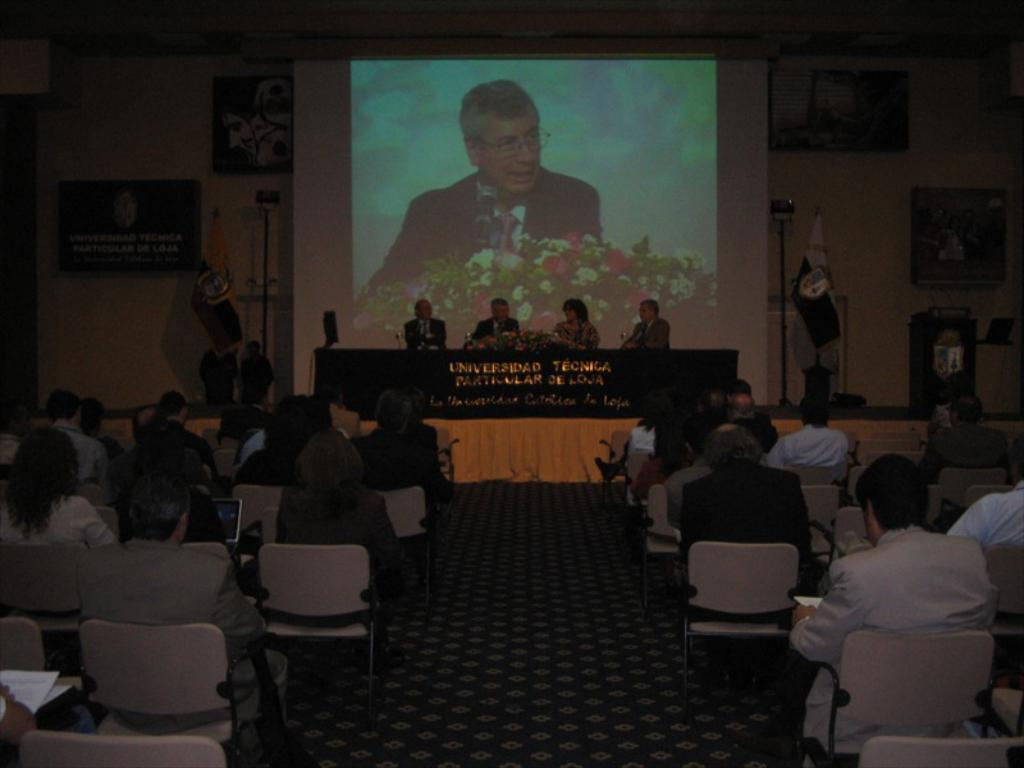What are the people in the image doing? There is a group of people sitting on chairs in the image. What can be seen on the wall behind the people? Boards are attached to the wall in the image. What is the purpose of the screen visible in the image? The purpose of the screen is not specified, but it is visible in the image. What is the flag associated with in the image? The flag is present in the image, but its specific association is not mentioned. What hobbies do the people sitting on chairs have in common? There is no information provided about the hobbies of the people sitting on chairs, so it cannot be determined from the image. 